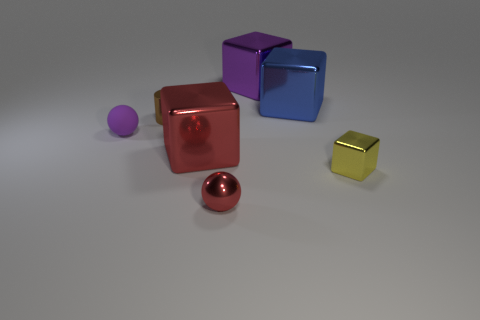How many geometric shapes are there in the image? There are five distinct geometric shapes in the image: two spheres, a small cube, and two large cubes. 